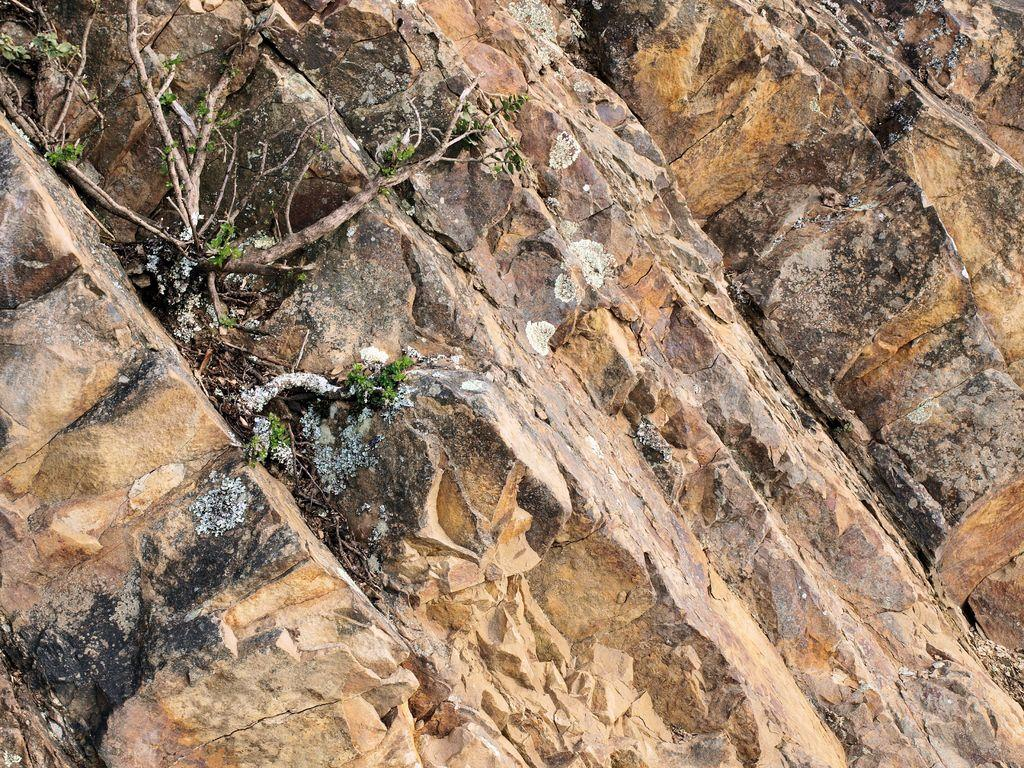What colors are used on the wall in the image? The wall in the image is cream and black in color. What can be seen on the right side of the image? There are plants on the right side of the image. What type of food is being prepared on the wall in the image? There is no food preparation visible in the image; it only features a wall and plants. Can you see any shoes hanging on the wall in the image? There are no shoes present in the image. 